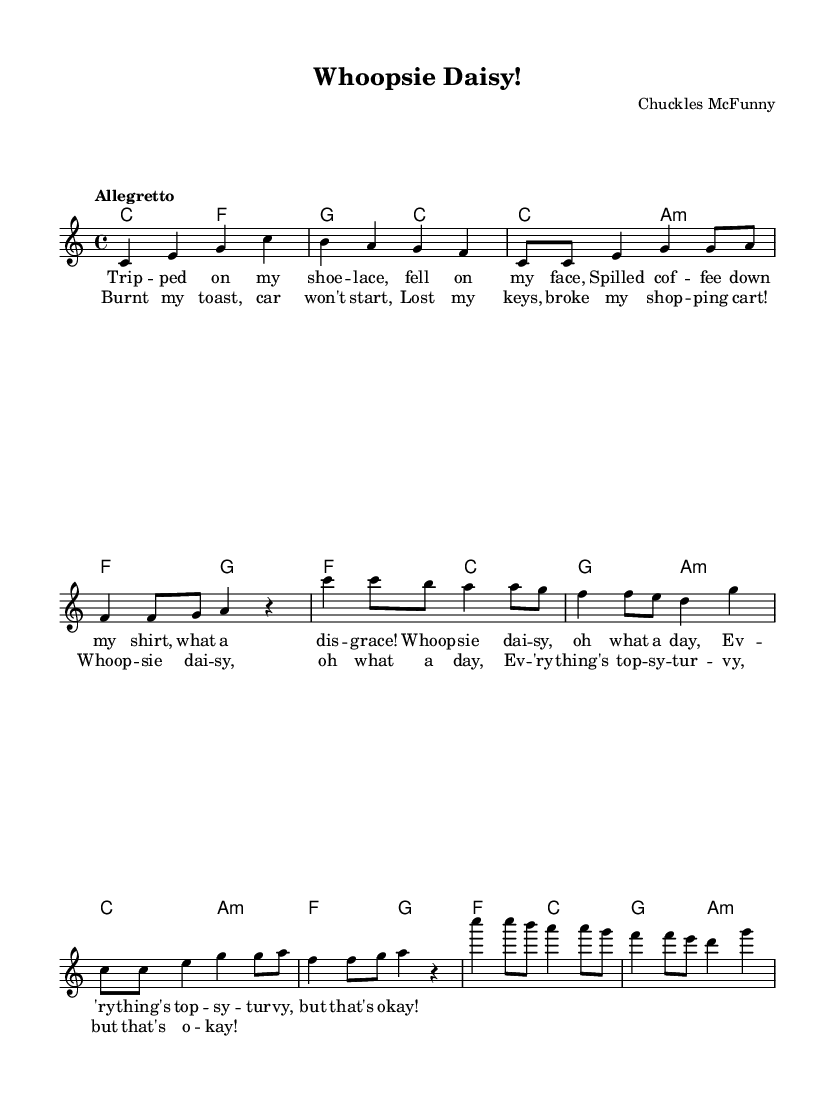What is the key signature of this music? The key signature is C major, which has no sharps or flats indicated at the beginning of the score.
Answer: C major What is the time signature of the piece? The time signature is 4/4, which means there are four beats in a measure with each quarter note getting one beat. It is indicated next to the clef at the beginning of the score.
Answer: 4/4 What is the tempo marking for this song? The tempo marking is "Allegretto," which suggests a moderately fast tempo. This is written above the staff after the clef and key signature.
Answer: Allegretto How many verses are in the song? The song contains two verses, as shown by the distinct lyric sections labeled as "Verse 1" and "Verse 2" in the lyrics below the melody.
Answer: Two What is the last lyric of the chorus? The last lyric of the chorus is "but that's o -- kay!", found at the end of the repeated chorus section of the lyrics.
Answer: but that's o -- kay! What is the primary theme of the song? The primary theme is everyday mishaps and blunders, inferred from the lyrics that describe various humorous unfortunate events. This is reflective of comedic novelty songs that celebrate the absurdity of daily life.
Answer: Everyday mishaps 